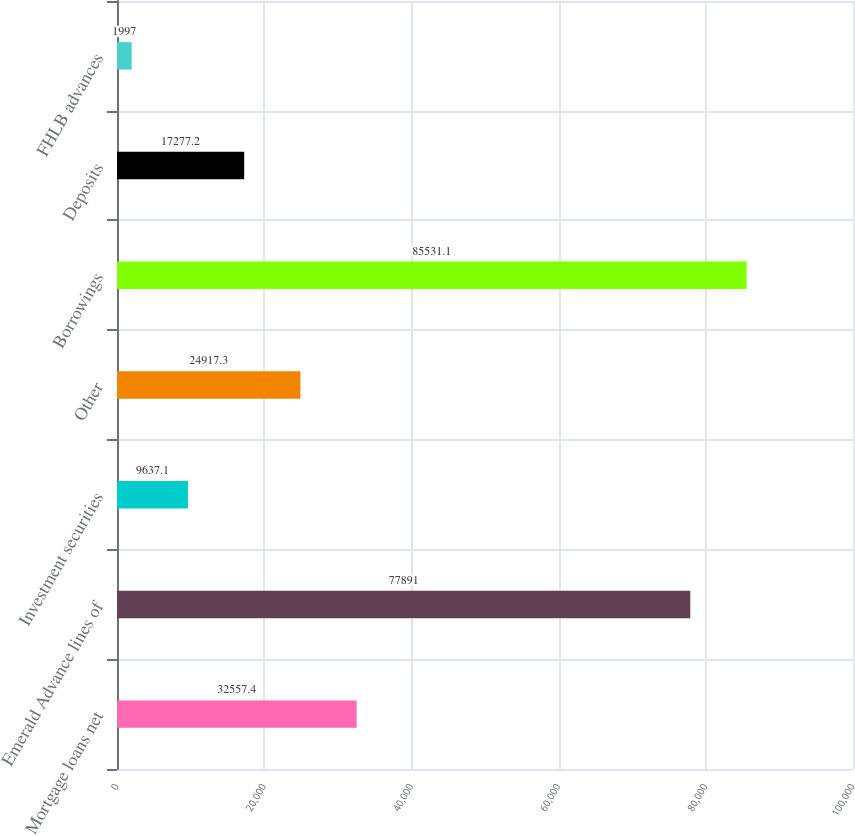Convert chart. <chart><loc_0><loc_0><loc_500><loc_500><bar_chart><fcel>Mortgage loans net<fcel>Emerald Advance lines of<fcel>Investment securities<fcel>Other<fcel>Borrowings<fcel>Deposits<fcel>FHLB advances<nl><fcel>32557.4<fcel>77891<fcel>9637.1<fcel>24917.3<fcel>85531.1<fcel>17277.2<fcel>1997<nl></chart> 